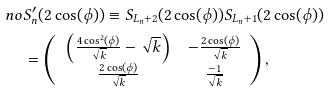Convert formula to latex. <formula><loc_0><loc_0><loc_500><loc_500>\ n o & S ^ { \prime } _ { n } ( 2 \cos ( \phi ) ) \equiv S _ { L _ { n } + 2 } ( 2 \cos ( \phi ) ) S _ { L _ { n } + 1 } ( 2 \cos ( \phi ) ) \\ & = \left ( \begin{array} { c c } \left ( \frac { 4 \cos ^ { 2 } ( \phi ) } { \sqrt { k } } - \sqrt { k } \right ) & - \frac { 2 \cos ( \phi ) } { \sqrt { k } } \\ \frac { 2 \cos ( \phi ) } { \sqrt { k } } & \frac { - 1 } { \sqrt { k } } \end{array} \right ) ,</formula> 